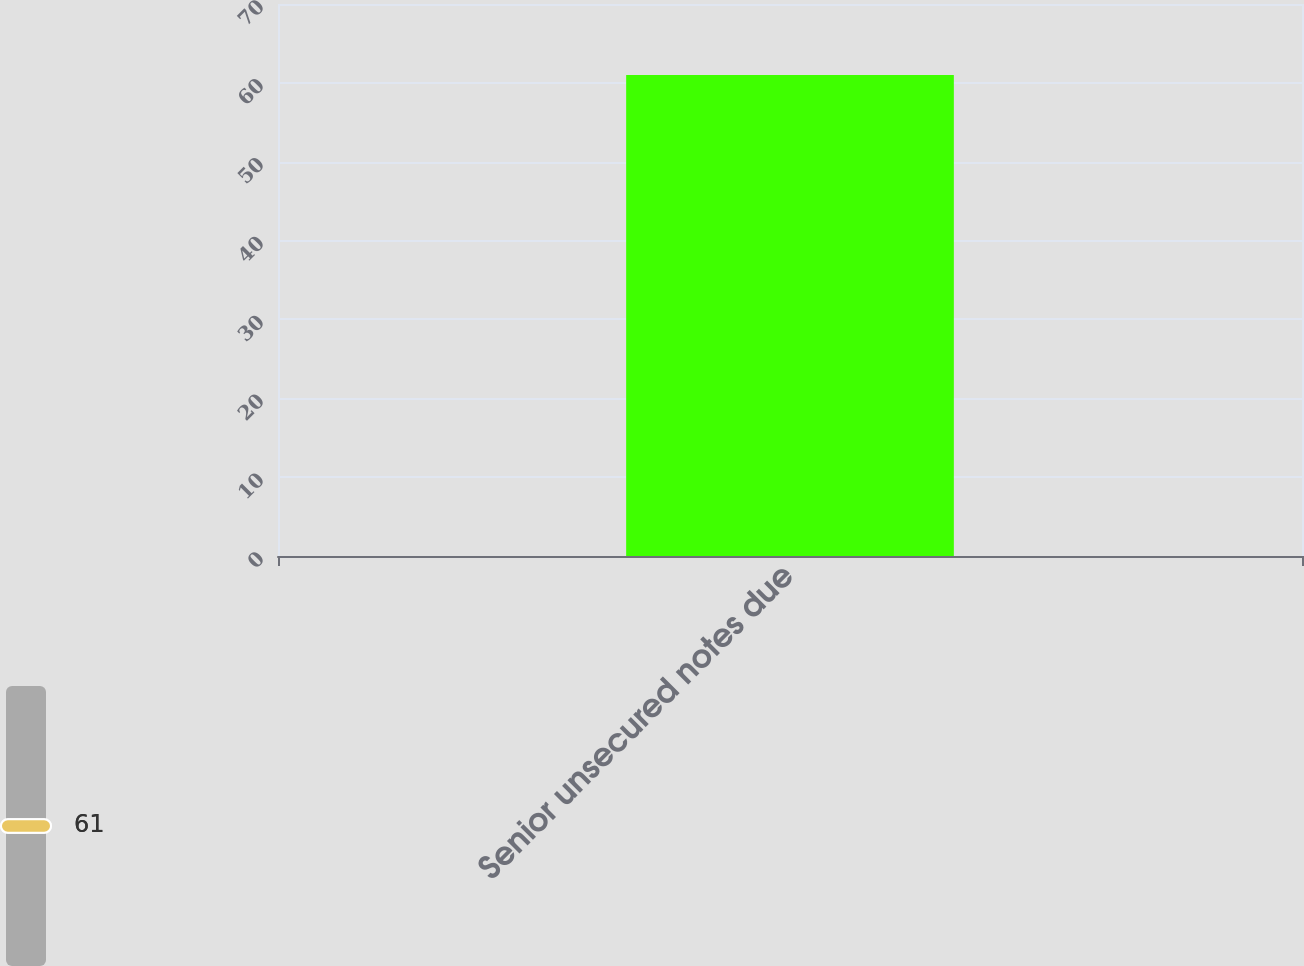Convert chart. <chart><loc_0><loc_0><loc_500><loc_500><bar_chart><fcel>Senior unsecured notes due<nl><fcel>61<nl></chart> 